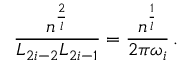<formula> <loc_0><loc_0><loc_500><loc_500>\frac { n ^ { \frac { 2 } { l } } } { L _ { 2 i - 2 } L _ { 2 i - 1 } } = \frac { n ^ { \frac { 1 } { l } } } { 2 \pi \omega _ { i } } \, .</formula> 